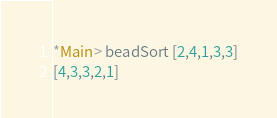Convert code to text. <code><loc_0><loc_0><loc_500><loc_500><_Haskell_>*Main> beadSort [2,4,1,3,3]
[4,3,3,2,1]
</code> 